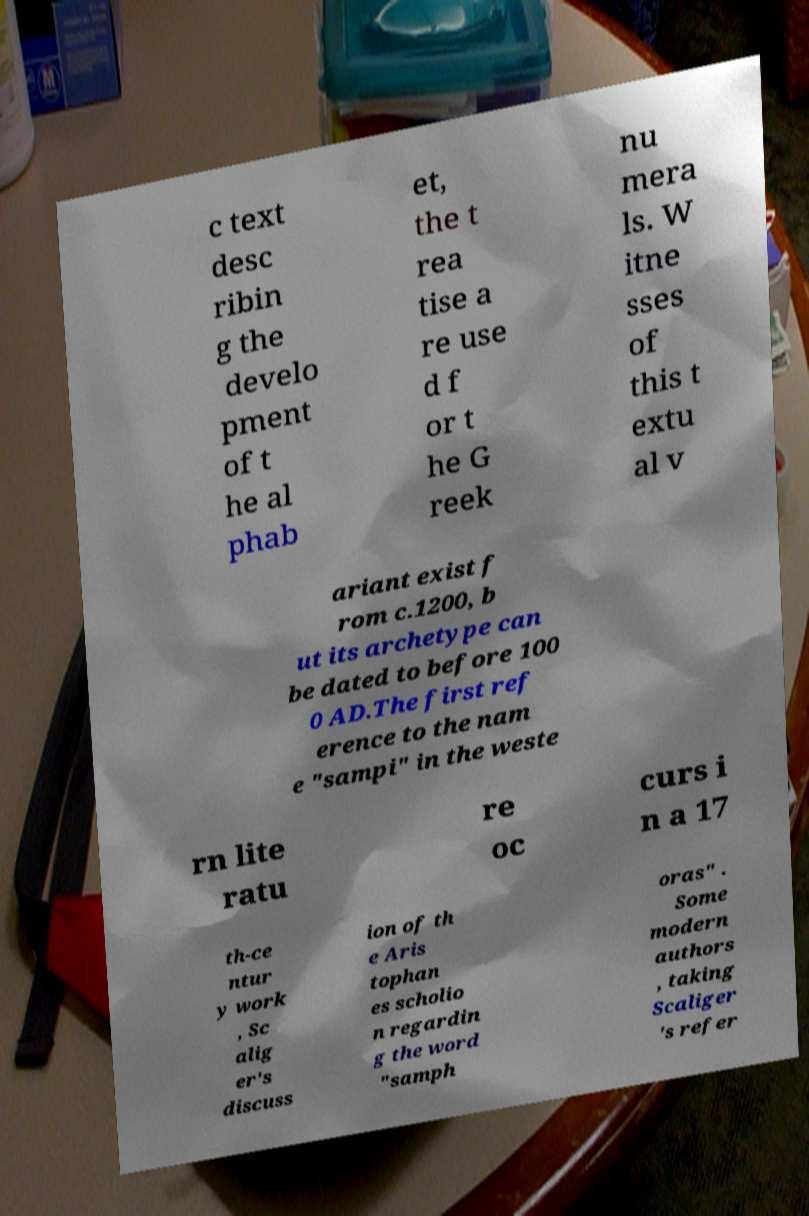There's text embedded in this image that I need extracted. Can you transcribe it verbatim? c text desc ribin g the develo pment of t he al phab et, the t rea tise a re use d f or t he G reek nu mera ls. W itne sses of this t extu al v ariant exist f rom c.1200, b ut its archetype can be dated to before 100 0 AD.The first ref erence to the nam e "sampi" in the weste rn lite ratu re oc curs i n a 17 th-ce ntur y work , Sc alig er's discuss ion of th e Aris tophan es scholio n regardin g the word "samph oras" . Some modern authors , taking Scaliger 's refer 